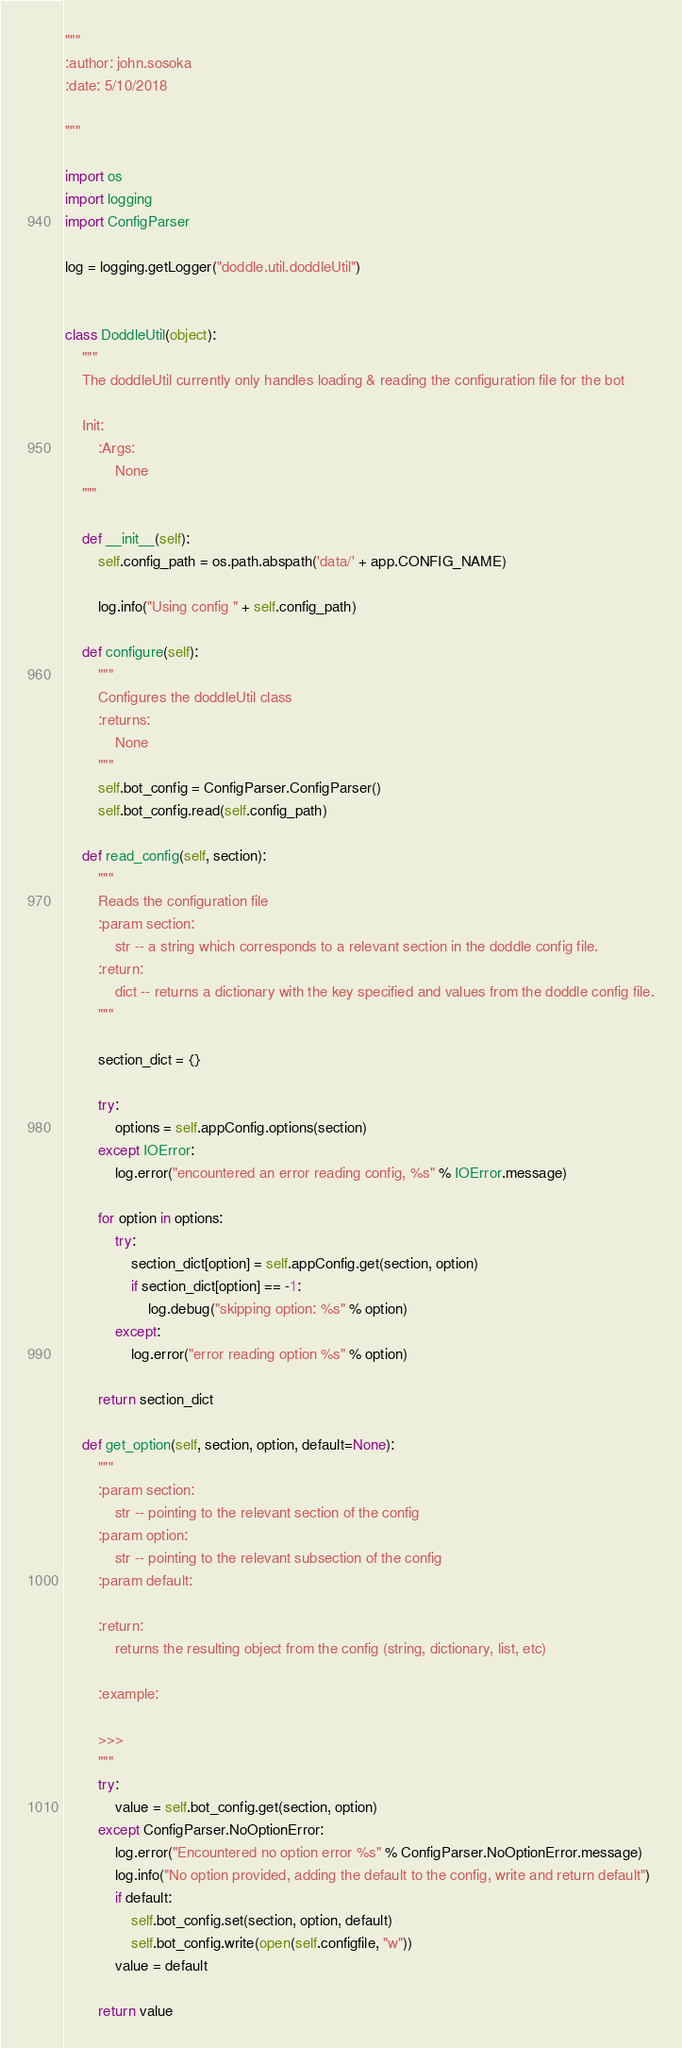<code> <loc_0><loc_0><loc_500><loc_500><_Python_>"""
:author: john.sosoka
:date: 5/10/2018

"""

import os
import logging
import ConfigParser

log = logging.getLogger("doddle.util.doddleUtil")


class DoddleUtil(object):
    """
    The doddleUtil currently only handles loading & reading the configuration file for the bot

    Init:
        :Args:
            None
    """

    def __init__(self):
        self.config_path = os.path.abspath('data/' + app.CONFIG_NAME)

        log.info("Using config " + self.config_path)

    def configure(self):
        """
        Configures the doddleUtil class
        :returns:
            None
        """
        self.bot_config = ConfigParser.ConfigParser()
        self.bot_config.read(self.config_path)

    def read_config(self, section):
        """
        Reads the configuration file
        :param section:
            str -- a string which corresponds to a relevant section in the doddle config file.
        :return:
            dict -- returns a dictionary with the key specified and values from the doddle config file.
        """

        section_dict = {}

        try:
            options = self.appConfig.options(section)
        except IOError:
            log.error("encountered an error reading config, %s" % IOError.message)

        for option in options:
            try:
                section_dict[option] = self.appConfig.get(section, option)
                if section_dict[option] == -1:
                    log.debug("skipping option: %s" % option)
            except:
                log.error("error reading option %s" % option)

        return section_dict

    def get_option(self, section, option, default=None):
        """
        :param section:
            str -- pointing to the relevant section of the config
        :param option:
            str -- pointing to the relevant subsection of the config
        :param default:

        :return:
            returns the resulting object from the config (string, dictionary, list, etc)

        :example:

        >>>
        """
        try:
            value = self.bot_config.get(section, option)
        except ConfigParser.NoOptionError:
            log.error("Encountered no option error %s" % ConfigParser.NoOptionError.message)
            log.info("No option provided, adding the default to the config, write and return default")
            if default:
                self.bot_config.set(section, option, default)
                self.bot_config.write(open(self.configfile, "w"))
            value = default

        return value
</code> 